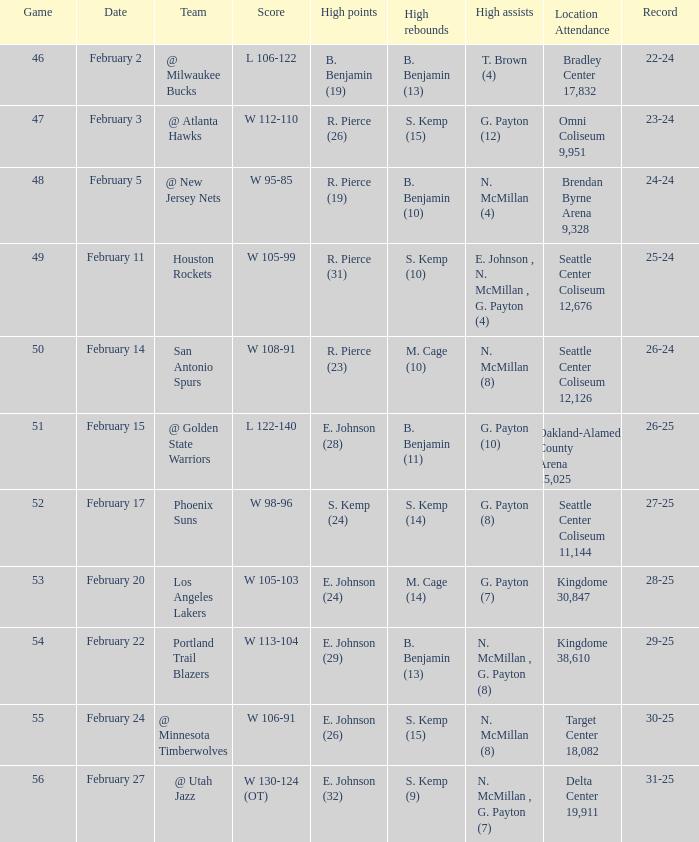In which game was the score w 95-85? 48.0. 